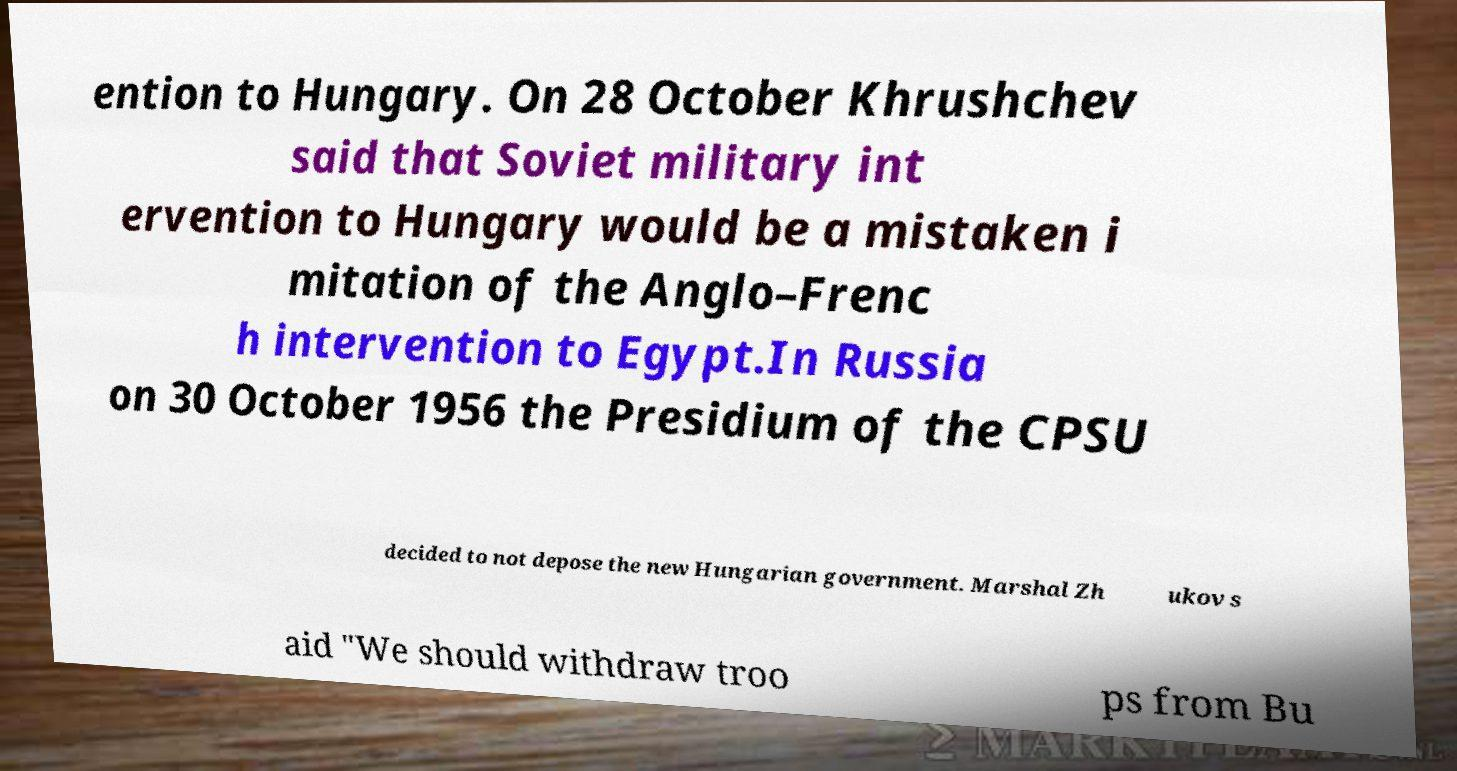What messages or text are displayed in this image? I need them in a readable, typed format. ention to Hungary. On 28 October Khrushchev said that Soviet military int ervention to Hungary would be a mistaken i mitation of the Anglo–Frenc h intervention to Egypt.In Russia on 30 October 1956 the Presidium of the CPSU decided to not depose the new Hungarian government. Marshal Zh ukov s aid "We should withdraw troo ps from Bu 